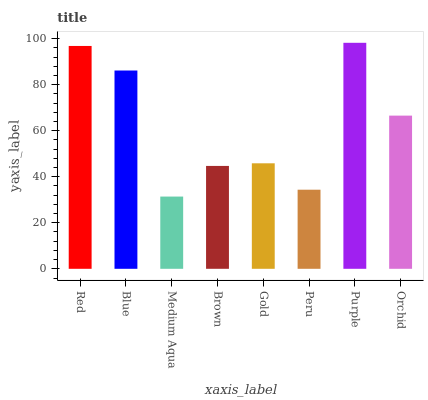Is Blue the minimum?
Answer yes or no. No. Is Blue the maximum?
Answer yes or no. No. Is Red greater than Blue?
Answer yes or no. Yes. Is Blue less than Red?
Answer yes or no. Yes. Is Blue greater than Red?
Answer yes or no. No. Is Red less than Blue?
Answer yes or no. No. Is Orchid the high median?
Answer yes or no. Yes. Is Gold the low median?
Answer yes or no. Yes. Is Brown the high median?
Answer yes or no. No. Is Brown the low median?
Answer yes or no. No. 